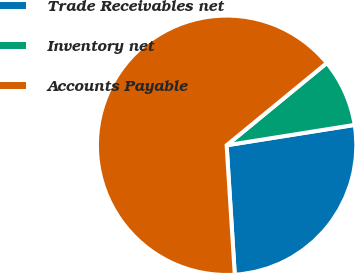Convert chart to OTSL. <chart><loc_0><loc_0><loc_500><loc_500><pie_chart><fcel>Trade Receivables net<fcel>Inventory net<fcel>Accounts Payable<nl><fcel>26.51%<fcel>8.43%<fcel>65.06%<nl></chart> 